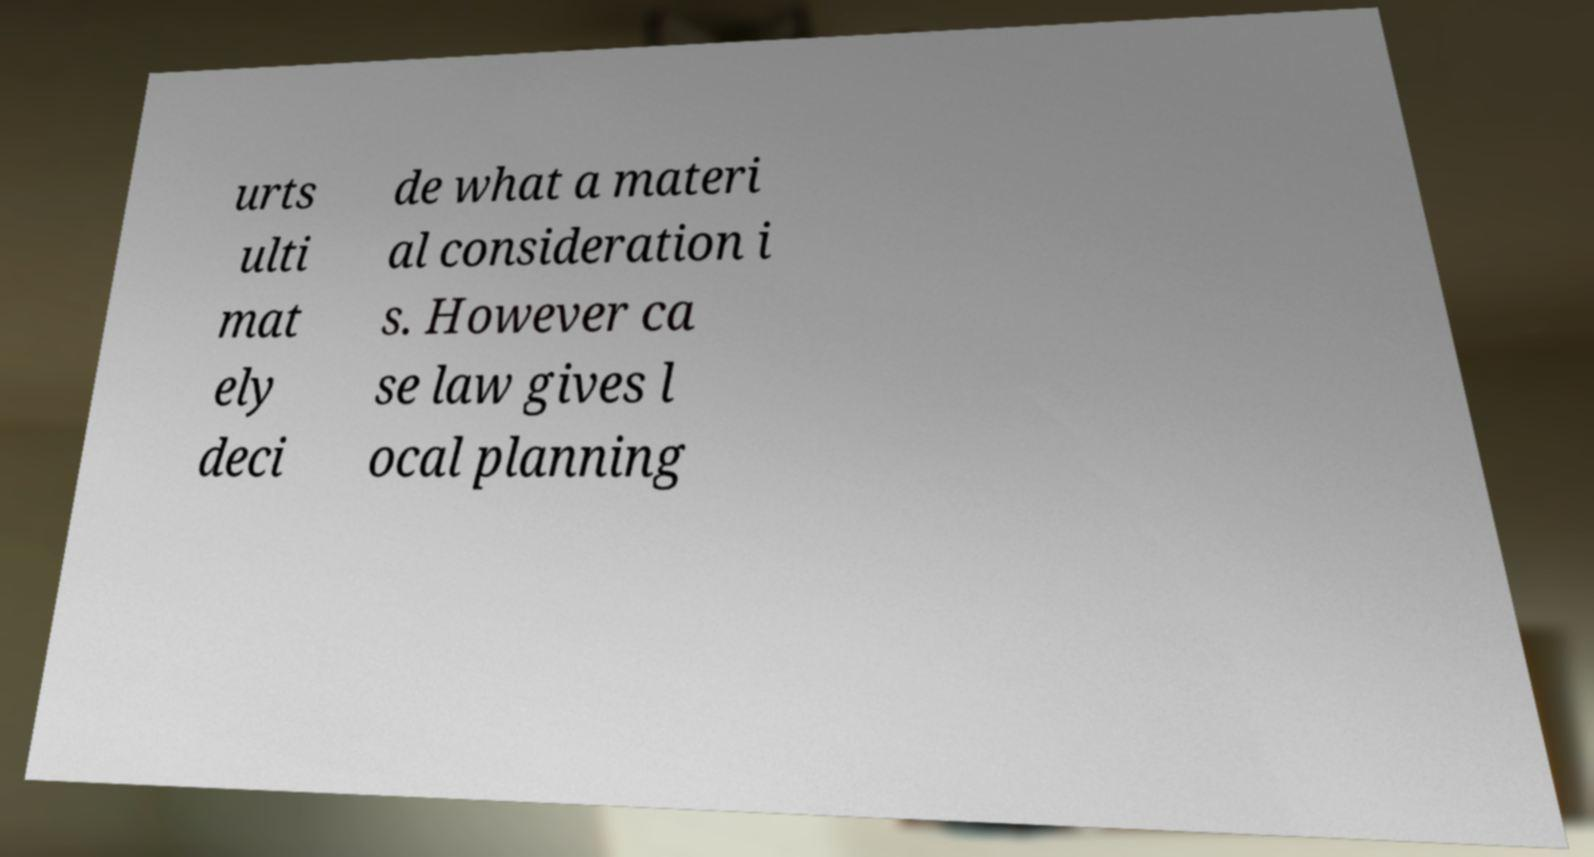For documentation purposes, I need the text within this image transcribed. Could you provide that? urts ulti mat ely deci de what a materi al consideration i s. However ca se law gives l ocal planning 